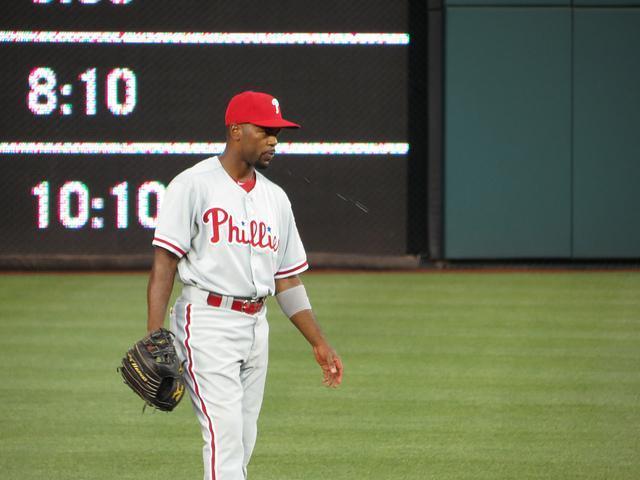How many people are to the left of the motorcycles in this image?
Give a very brief answer. 0. 